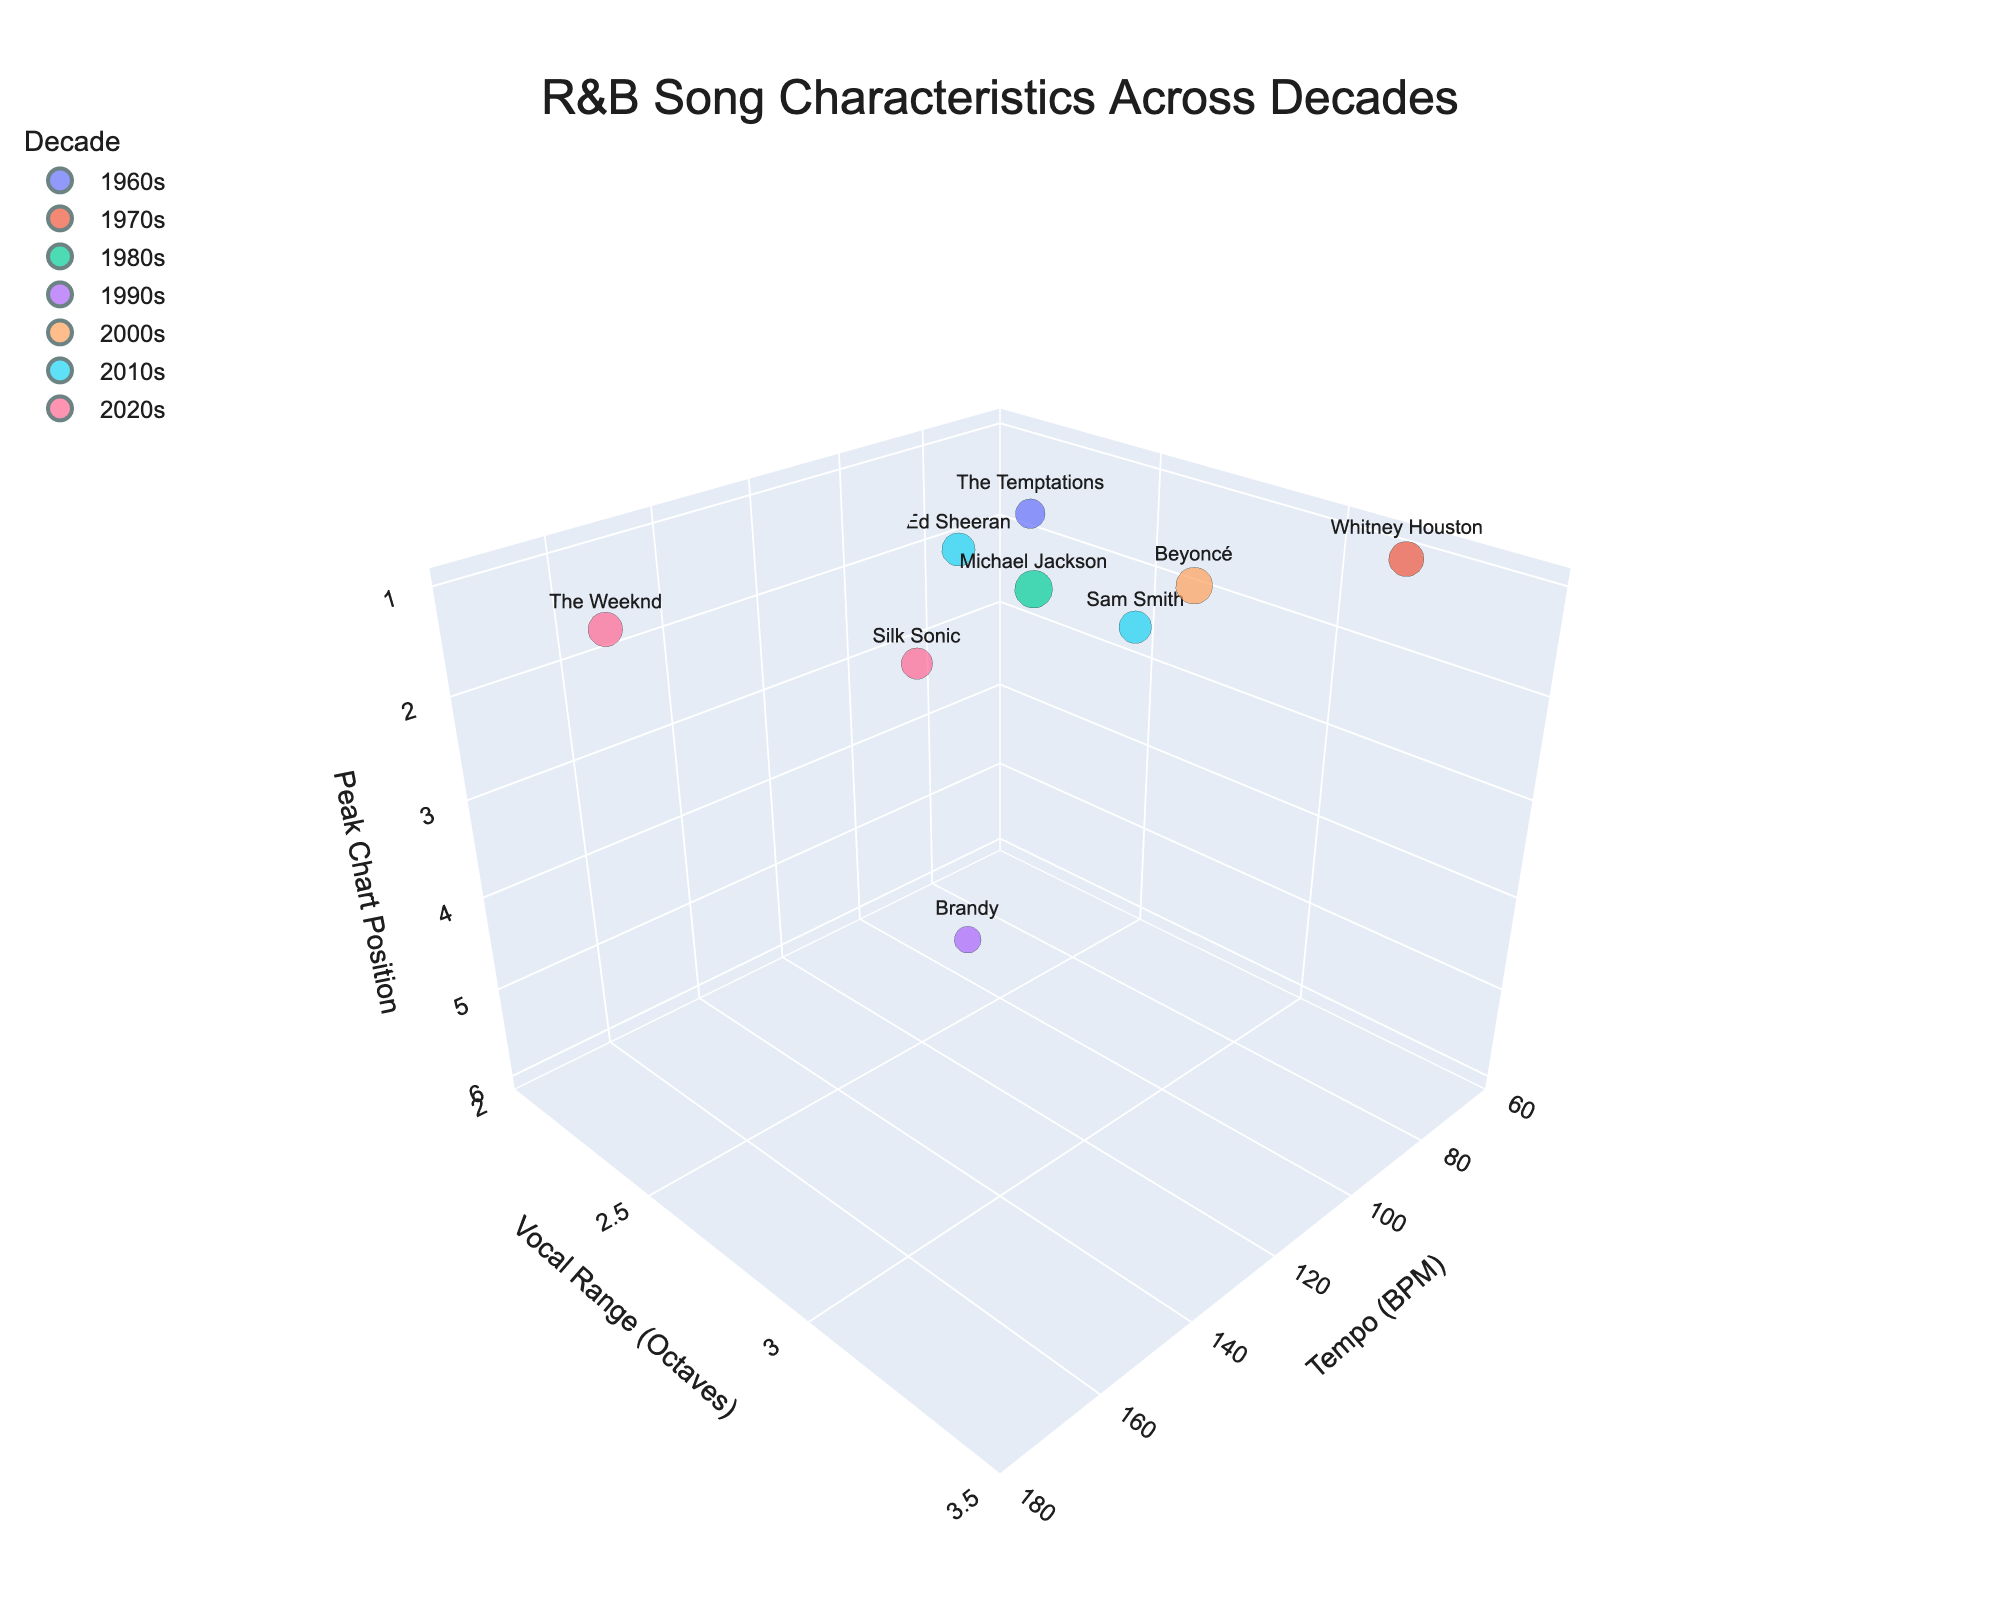What's the title of the figure? The title is prominently displayed at the top of the figure. It is "R&B Song Characteristics Across Decades."
Answer: R&B Song Characteristics Across Decades How many songs are represented in the 2020s? The 2020s decade can be identified by its color in the legend. There are two data points in that color: “Blinding Lights” by The Weeknd and “Leave The Door Open” by Silk Sonic.
Answer: 2 What's the tempo (BPM) range for the songs in the chart? Referring to the x-axis of the chart which represents the tempo (BPM), the range is shown from 60 to 180 BPM.
Answer: 60 to 180 BPM Which song has the largest bubble, and what does it signify? The largest bubble represents the highest average weekly sales. By inspecting the bubble sizes, “Billie Jean” by Michael Jackson has the largest bubble.
Answer: Billie Jean How does the tempo of "Blinding Lights" compare to "Crazy in Love"? “Blinding Lights” by The Weeknd has a tempo of 171 BPM, while “Crazy in Love” by Beyoncé stands at 99 BPM. Comparing them, “Blinding Lights” has a higher tempo.
Answer: Blinding Lights has a higher tempo What is the general trend of vocal range by decade? By observing the y-axis trends across different colored bubbles (each representing a different decade), there is no clear increasing or decreasing trend of vocal range from decade to decade, indicating variability.
Answer: No clear trend What's the average peak chart position of songs from the 2010s? There are two songs from the 2010s: “Thinking Out Loud” with a peak chart position of 2 and “Stay With Me” also with a peak chart position of 2. Average = (2 + 2)/2 = 2.
Answer: 2 Which decade features a song with both the highest tempo and the lowest peak chart position? The highest tempo is 171 BPM for "Blinding Lights" from the 2020s, and the lowest peak chart position (which is the highest actual ranking) is 1. The 2020s decade meets both criteria.
Answer: 2020s Which song has the widest vocal range, and what are its characteristics? The song with the widest vocal range has the highest position on the y-axis. "I Will Always Love You" by Whitney Houston has a vocal range of 3.2 octaves, tempo of 67 BPM, peak chart position of 1, and average weekly sales of 150000.
Answer: I Will Always Love You (Whitney Houston) Is there a relationship between tempo and chart performance for the highest-selling songs? By examining the largest bubbles (which indicate high average weekly sales) and their position along the x-axis (tempo), most of the highest-selling songs do not reside at extreme tempos. Instead, they are more centrally located (e.g., “Billie Jean” at 117 BPM). This suggests no strong correlation between extreme tempo and better chart performance.
Answer: No strong relationship 